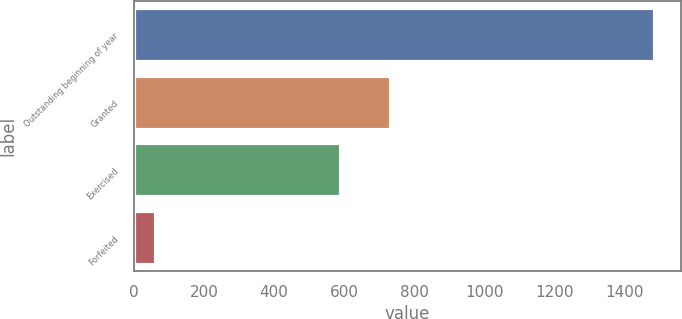Convert chart. <chart><loc_0><loc_0><loc_500><loc_500><bar_chart><fcel>Outstanding beginning of year<fcel>Granted<fcel>Exercised<fcel>Forfeited<nl><fcel>1486<fcel>734.4<fcel>592<fcel>62<nl></chart> 